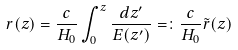Convert formula to latex. <formula><loc_0><loc_0><loc_500><loc_500>r ( z ) = \frac { c } { H _ { 0 } } \int _ { 0 } ^ { z } \frac { d z ^ { \prime } } { E ( z ^ { \prime } ) } = \colon \frac { c } { H _ { 0 } } { \tilde { r } } ( z )</formula> 